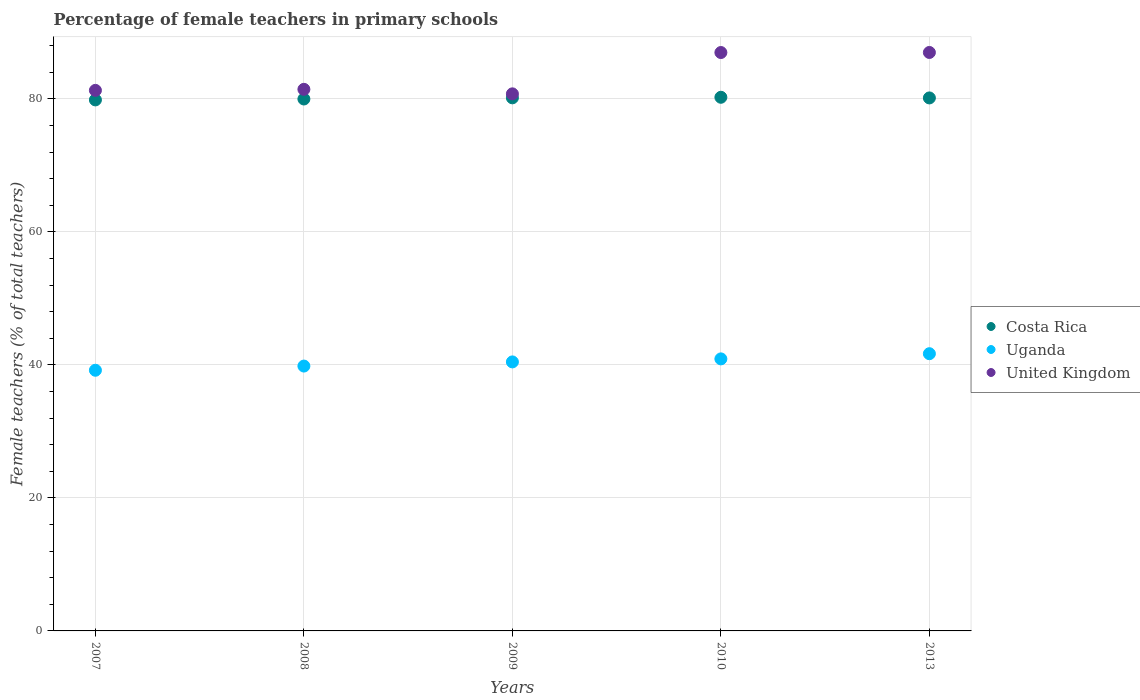How many different coloured dotlines are there?
Provide a succinct answer. 3. Is the number of dotlines equal to the number of legend labels?
Your answer should be very brief. Yes. What is the percentage of female teachers in Uganda in 2010?
Your answer should be very brief. 40.91. Across all years, what is the maximum percentage of female teachers in Costa Rica?
Your answer should be compact. 80.25. Across all years, what is the minimum percentage of female teachers in Uganda?
Offer a very short reply. 39.2. In which year was the percentage of female teachers in Costa Rica maximum?
Your answer should be compact. 2010. What is the total percentage of female teachers in Uganda in the graph?
Make the answer very short. 202.07. What is the difference between the percentage of female teachers in United Kingdom in 2010 and that in 2013?
Provide a succinct answer. -0.01. What is the difference between the percentage of female teachers in Uganda in 2009 and the percentage of female teachers in United Kingdom in 2008?
Ensure brevity in your answer.  -40.99. What is the average percentage of female teachers in Costa Rica per year?
Give a very brief answer. 80.08. In the year 2007, what is the difference between the percentage of female teachers in Costa Rica and percentage of female teachers in United Kingdom?
Keep it short and to the point. -1.43. In how many years, is the percentage of female teachers in Uganda greater than 24 %?
Offer a very short reply. 5. What is the ratio of the percentage of female teachers in Uganda in 2007 to that in 2008?
Your answer should be compact. 0.98. Is the percentage of female teachers in Uganda in 2007 less than that in 2009?
Your answer should be compact. Yes. What is the difference between the highest and the second highest percentage of female teachers in Uganda?
Your response must be concise. 0.78. What is the difference between the highest and the lowest percentage of female teachers in United Kingdom?
Offer a very short reply. 6.22. Is it the case that in every year, the sum of the percentage of female teachers in Uganda and percentage of female teachers in Costa Rica  is greater than the percentage of female teachers in United Kingdom?
Provide a short and direct response. Yes. Does the percentage of female teachers in Costa Rica monotonically increase over the years?
Your response must be concise. No. Is the percentage of female teachers in United Kingdom strictly greater than the percentage of female teachers in Uganda over the years?
Offer a very short reply. Yes. How many dotlines are there?
Provide a succinct answer. 3. Does the graph contain grids?
Your response must be concise. Yes. What is the title of the graph?
Provide a short and direct response. Percentage of female teachers in primary schools. What is the label or title of the X-axis?
Offer a terse response. Years. What is the label or title of the Y-axis?
Ensure brevity in your answer.  Female teachers (% of total teachers). What is the Female teachers (% of total teachers) of Costa Rica in 2007?
Provide a succinct answer. 79.85. What is the Female teachers (% of total teachers) of Uganda in 2007?
Provide a short and direct response. 39.2. What is the Female teachers (% of total teachers) of United Kingdom in 2007?
Your response must be concise. 81.28. What is the Female teachers (% of total teachers) in Costa Rica in 2008?
Ensure brevity in your answer.  79.99. What is the Female teachers (% of total teachers) of Uganda in 2008?
Provide a succinct answer. 39.83. What is the Female teachers (% of total teachers) of United Kingdom in 2008?
Provide a short and direct response. 81.44. What is the Female teachers (% of total teachers) in Costa Rica in 2009?
Provide a short and direct response. 80.16. What is the Female teachers (% of total teachers) of Uganda in 2009?
Your response must be concise. 40.45. What is the Female teachers (% of total teachers) of United Kingdom in 2009?
Offer a very short reply. 80.76. What is the Female teachers (% of total teachers) of Costa Rica in 2010?
Your answer should be compact. 80.25. What is the Female teachers (% of total teachers) of Uganda in 2010?
Your response must be concise. 40.91. What is the Female teachers (% of total teachers) of United Kingdom in 2010?
Make the answer very short. 86.98. What is the Female teachers (% of total teachers) of Costa Rica in 2013?
Your answer should be very brief. 80.15. What is the Female teachers (% of total teachers) in Uganda in 2013?
Ensure brevity in your answer.  41.69. What is the Female teachers (% of total teachers) of United Kingdom in 2013?
Provide a short and direct response. 86.98. Across all years, what is the maximum Female teachers (% of total teachers) in Costa Rica?
Give a very brief answer. 80.25. Across all years, what is the maximum Female teachers (% of total teachers) of Uganda?
Give a very brief answer. 41.69. Across all years, what is the maximum Female teachers (% of total teachers) in United Kingdom?
Your answer should be very brief. 86.98. Across all years, what is the minimum Female teachers (% of total teachers) of Costa Rica?
Your response must be concise. 79.85. Across all years, what is the minimum Female teachers (% of total teachers) of Uganda?
Provide a short and direct response. 39.2. Across all years, what is the minimum Female teachers (% of total teachers) of United Kingdom?
Your response must be concise. 80.76. What is the total Female teachers (% of total teachers) of Costa Rica in the graph?
Your answer should be very brief. 400.39. What is the total Female teachers (% of total teachers) in Uganda in the graph?
Give a very brief answer. 202.07. What is the total Female teachers (% of total teachers) in United Kingdom in the graph?
Provide a short and direct response. 417.45. What is the difference between the Female teachers (% of total teachers) of Costa Rica in 2007 and that in 2008?
Offer a very short reply. -0.14. What is the difference between the Female teachers (% of total teachers) of Uganda in 2007 and that in 2008?
Make the answer very short. -0.63. What is the difference between the Female teachers (% of total teachers) in United Kingdom in 2007 and that in 2008?
Give a very brief answer. -0.16. What is the difference between the Female teachers (% of total teachers) of Costa Rica in 2007 and that in 2009?
Provide a succinct answer. -0.31. What is the difference between the Female teachers (% of total teachers) in Uganda in 2007 and that in 2009?
Your answer should be compact. -1.25. What is the difference between the Female teachers (% of total teachers) in United Kingdom in 2007 and that in 2009?
Ensure brevity in your answer.  0.52. What is the difference between the Female teachers (% of total teachers) in Costa Rica in 2007 and that in 2010?
Provide a short and direct response. -0.4. What is the difference between the Female teachers (% of total teachers) in Uganda in 2007 and that in 2010?
Your response must be concise. -1.71. What is the difference between the Female teachers (% of total teachers) in United Kingdom in 2007 and that in 2010?
Provide a succinct answer. -5.69. What is the difference between the Female teachers (% of total teachers) of Costa Rica in 2007 and that in 2013?
Offer a terse response. -0.3. What is the difference between the Female teachers (% of total teachers) of Uganda in 2007 and that in 2013?
Provide a succinct answer. -2.49. What is the difference between the Female teachers (% of total teachers) of United Kingdom in 2007 and that in 2013?
Keep it short and to the point. -5.7. What is the difference between the Female teachers (% of total teachers) of Costa Rica in 2008 and that in 2009?
Offer a very short reply. -0.17. What is the difference between the Female teachers (% of total teachers) of Uganda in 2008 and that in 2009?
Your answer should be very brief. -0.62. What is the difference between the Female teachers (% of total teachers) in United Kingdom in 2008 and that in 2009?
Offer a terse response. 0.68. What is the difference between the Female teachers (% of total teachers) of Costa Rica in 2008 and that in 2010?
Your answer should be compact. -0.26. What is the difference between the Female teachers (% of total teachers) of Uganda in 2008 and that in 2010?
Your response must be concise. -1.08. What is the difference between the Female teachers (% of total teachers) of United Kingdom in 2008 and that in 2010?
Offer a very short reply. -5.53. What is the difference between the Female teachers (% of total teachers) of Costa Rica in 2008 and that in 2013?
Your response must be concise. -0.16. What is the difference between the Female teachers (% of total teachers) in Uganda in 2008 and that in 2013?
Provide a succinct answer. -1.86. What is the difference between the Female teachers (% of total teachers) in United Kingdom in 2008 and that in 2013?
Offer a very short reply. -5.54. What is the difference between the Female teachers (% of total teachers) in Costa Rica in 2009 and that in 2010?
Provide a short and direct response. -0.08. What is the difference between the Female teachers (% of total teachers) of Uganda in 2009 and that in 2010?
Make the answer very short. -0.45. What is the difference between the Female teachers (% of total teachers) in United Kingdom in 2009 and that in 2010?
Give a very brief answer. -6.21. What is the difference between the Female teachers (% of total teachers) of Costa Rica in 2009 and that in 2013?
Provide a short and direct response. 0.01. What is the difference between the Female teachers (% of total teachers) of Uganda in 2009 and that in 2013?
Offer a terse response. -1.23. What is the difference between the Female teachers (% of total teachers) in United Kingdom in 2009 and that in 2013?
Provide a short and direct response. -6.22. What is the difference between the Female teachers (% of total teachers) of Costa Rica in 2010 and that in 2013?
Your response must be concise. 0.1. What is the difference between the Female teachers (% of total teachers) in Uganda in 2010 and that in 2013?
Your response must be concise. -0.78. What is the difference between the Female teachers (% of total teachers) of United Kingdom in 2010 and that in 2013?
Your answer should be very brief. -0.01. What is the difference between the Female teachers (% of total teachers) of Costa Rica in 2007 and the Female teachers (% of total teachers) of Uganda in 2008?
Ensure brevity in your answer.  40.02. What is the difference between the Female teachers (% of total teachers) of Costa Rica in 2007 and the Female teachers (% of total teachers) of United Kingdom in 2008?
Your response must be concise. -1.59. What is the difference between the Female teachers (% of total teachers) of Uganda in 2007 and the Female teachers (% of total teachers) of United Kingdom in 2008?
Your answer should be very brief. -42.24. What is the difference between the Female teachers (% of total teachers) of Costa Rica in 2007 and the Female teachers (% of total teachers) of Uganda in 2009?
Make the answer very short. 39.4. What is the difference between the Female teachers (% of total teachers) in Costa Rica in 2007 and the Female teachers (% of total teachers) in United Kingdom in 2009?
Give a very brief answer. -0.91. What is the difference between the Female teachers (% of total teachers) in Uganda in 2007 and the Female teachers (% of total teachers) in United Kingdom in 2009?
Provide a succinct answer. -41.56. What is the difference between the Female teachers (% of total teachers) of Costa Rica in 2007 and the Female teachers (% of total teachers) of Uganda in 2010?
Your response must be concise. 38.94. What is the difference between the Female teachers (% of total teachers) of Costa Rica in 2007 and the Female teachers (% of total teachers) of United Kingdom in 2010?
Make the answer very short. -7.13. What is the difference between the Female teachers (% of total teachers) in Uganda in 2007 and the Female teachers (% of total teachers) in United Kingdom in 2010?
Keep it short and to the point. -47.78. What is the difference between the Female teachers (% of total teachers) of Costa Rica in 2007 and the Female teachers (% of total teachers) of Uganda in 2013?
Ensure brevity in your answer.  38.16. What is the difference between the Female teachers (% of total teachers) of Costa Rica in 2007 and the Female teachers (% of total teachers) of United Kingdom in 2013?
Your answer should be very brief. -7.13. What is the difference between the Female teachers (% of total teachers) of Uganda in 2007 and the Female teachers (% of total teachers) of United Kingdom in 2013?
Give a very brief answer. -47.79. What is the difference between the Female teachers (% of total teachers) in Costa Rica in 2008 and the Female teachers (% of total teachers) in Uganda in 2009?
Provide a succinct answer. 39.53. What is the difference between the Female teachers (% of total teachers) in Costa Rica in 2008 and the Female teachers (% of total teachers) in United Kingdom in 2009?
Provide a short and direct response. -0.77. What is the difference between the Female teachers (% of total teachers) in Uganda in 2008 and the Female teachers (% of total teachers) in United Kingdom in 2009?
Provide a succinct answer. -40.93. What is the difference between the Female teachers (% of total teachers) in Costa Rica in 2008 and the Female teachers (% of total teachers) in Uganda in 2010?
Keep it short and to the point. 39.08. What is the difference between the Female teachers (% of total teachers) in Costa Rica in 2008 and the Female teachers (% of total teachers) in United Kingdom in 2010?
Offer a very short reply. -6.99. What is the difference between the Female teachers (% of total teachers) of Uganda in 2008 and the Female teachers (% of total teachers) of United Kingdom in 2010?
Ensure brevity in your answer.  -47.15. What is the difference between the Female teachers (% of total teachers) of Costa Rica in 2008 and the Female teachers (% of total teachers) of Uganda in 2013?
Make the answer very short. 38.3. What is the difference between the Female teachers (% of total teachers) in Costa Rica in 2008 and the Female teachers (% of total teachers) in United Kingdom in 2013?
Give a very brief answer. -7. What is the difference between the Female teachers (% of total teachers) in Uganda in 2008 and the Female teachers (% of total teachers) in United Kingdom in 2013?
Your response must be concise. -47.16. What is the difference between the Female teachers (% of total teachers) in Costa Rica in 2009 and the Female teachers (% of total teachers) in Uganda in 2010?
Your answer should be compact. 39.25. What is the difference between the Female teachers (% of total teachers) of Costa Rica in 2009 and the Female teachers (% of total teachers) of United Kingdom in 2010?
Give a very brief answer. -6.81. What is the difference between the Female teachers (% of total teachers) of Uganda in 2009 and the Female teachers (% of total teachers) of United Kingdom in 2010?
Provide a short and direct response. -46.52. What is the difference between the Female teachers (% of total teachers) in Costa Rica in 2009 and the Female teachers (% of total teachers) in Uganda in 2013?
Provide a short and direct response. 38.48. What is the difference between the Female teachers (% of total teachers) in Costa Rica in 2009 and the Female teachers (% of total teachers) in United Kingdom in 2013?
Keep it short and to the point. -6.82. What is the difference between the Female teachers (% of total teachers) in Uganda in 2009 and the Female teachers (% of total teachers) in United Kingdom in 2013?
Provide a succinct answer. -46.53. What is the difference between the Female teachers (% of total teachers) of Costa Rica in 2010 and the Female teachers (% of total teachers) of Uganda in 2013?
Ensure brevity in your answer.  38.56. What is the difference between the Female teachers (% of total teachers) in Costa Rica in 2010 and the Female teachers (% of total teachers) in United Kingdom in 2013?
Ensure brevity in your answer.  -6.74. What is the difference between the Female teachers (% of total teachers) in Uganda in 2010 and the Female teachers (% of total teachers) in United Kingdom in 2013?
Offer a very short reply. -46.08. What is the average Female teachers (% of total teachers) in Costa Rica per year?
Ensure brevity in your answer.  80.08. What is the average Female teachers (% of total teachers) in Uganda per year?
Make the answer very short. 40.41. What is the average Female teachers (% of total teachers) of United Kingdom per year?
Offer a terse response. 83.49. In the year 2007, what is the difference between the Female teachers (% of total teachers) of Costa Rica and Female teachers (% of total teachers) of Uganda?
Make the answer very short. 40.65. In the year 2007, what is the difference between the Female teachers (% of total teachers) of Costa Rica and Female teachers (% of total teachers) of United Kingdom?
Your response must be concise. -1.43. In the year 2007, what is the difference between the Female teachers (% of total teachers) of Uganda and Female teachers (% of total teachers) of United Kingdom?
Your answer should be compact. -42.09. In the year 2008, what is the difference between the Female teachers (% of total teachers) of Costa Rica and Female teachers (% of total teachers) of Uganda?
Offer a terse response. 40.16. In the year 2008, what is the difference between the Female teachers (% of total teachers) of Costa Rica and Female teachers (% of total teachers) of United Kingdom?
Keep it short and to the point. -1.45. In the year 2008, what is the difference between the Female teachers (% of total teachers) of Uganda and Female teachers (% of total teachers) of United Kingdom?
Your answer should be compact. -41.61. In the year 2009, what is the difference between the Female teachers (% of total teachers) of Costa Rica and Female teachers (% of total teachers) of Uganda?
Offer a very short reply. 39.71. In the year 2009, what is the difference between the Female teachers (% of total teachers) in Costa Rica and Female teachers (% of total teachers) in United Kingdom?
Give a very brief answer. -0.6. In the year 2009, what is the difference between the Female teachers (% of total teachers) of Uganda and Female teachers (% of total teachers) of United Kingdom?
Offer a terse response. -40.31. In the year 2010, what is the difference between the Female teachers (% of total teachers) in Costa Rica and Female teachers (% of total teachers) in Uganda?
Provide a succinct answer. 39.34. In the year 2010, what is the difference between the Female teachers (% of total teachers) of Costa Rica and Female teachers (% of total teachers) of United Kingdom?
Make the answer very short. -6.73. In the year 2010, what is the difference between the Female teachers (% of total teachers) of Uganda and Female teachers (% of total teachers) of United Kingdom?
Provide a short and direct response. -46.07. In the year 2013, what is the difference between the Female teachers (% of total teachers) of Costa Rica and Female teachers (% of total teachers) of Uganda?
Provide a succinct answer. 38.46. In the year 2013, what is the difference between the Female teachers (% of total teachers) in Costa Rica and Female teachers (% of total teachers) in United Kingdom?
Provide a short and direct response. -6.84. In the year 2013, what is the difference between the Female teachers (% of total teachers) in Uganda and Female teachers (% of total teachers) in United Kingdom?
Give a very brief answer. -45.3. What is the ratio of the Female teachers (% of total teachers) in Uganda in 2007 to that in 2008?
Your answer should be very brief. 0.98. What is the ratio of the Female teachers (% of total teachers) of United Kingdom in 2007 to that in 2009?
Ensure brevity in your answer.  1.01. What is the ratio of the Female teachers (% of total teachers) in Uganda in 2007 to that in 2010?
Make the answer very short. 0.96. What is the ratio of the Female teachers (% of total teachers) in United Kingdom in 2007 to that in 2010?
Ensure brevity in your answer.  0.93. What is the ratio of the Female teachers (% of total teachers) of Uganda in 2007 to that in 2013?
Offer a very short reply. 0.94. What is the ratio of the Female teachers (% of total teachers) of United Kingdom in 2007 to that in 2013?
Offer a very short reply. 0.93. What is the ratio of the Female teachers (% of total teachers) in Uganda in 2008 to that in 2009?
Make the answer very short. 0.98. What is the ratio of the Female teachers (% of total teachers) in United Kingdom in 2008 to that in 2009?
Your answer should be compact. 1.01. What is the ratio of the Female teachers (% of total teachers) in Costa Rica in 2008 to that in 2010?
Offer a terse response. 1. What is the ratio of the Female teachers (% of total teachers) in Uganda in 2008 to that in 2010?
Your response must be concise. 0.97. What is the ratio of the Female teachers (% of total teachers) in United Kingdom in 2008 to that in 2010?
Offer a terse response. 0.94. What is the ratio of the Female teachers (% of total teachers) in Uganda in 2008 to that in 2013?
Ensure brevity in your answer.  0.96. What is the ratio of the Female teachers (% of total teachers) of United Kingdom in 2008 to that in 2013?
Make the answer very short. 0.94. What is the ratio of the Female teachers (% of total teachers) of Costa Rica in 2009 to that in 2010?
Your answer should be very brief. 1. What is the ratio of the Female teachers (% of total teachers) in Uganda in 2009 to that in 2010?
Ensure brevity in your answer.  0.99. What is the ratio of the Female teachers (% of total teachers) in United Kingdom in 2009 to that in 2010?
Ensure brevity in your answer.  0.93. What is the ratio of the Female teachers (% of total teachers) in Uganda in 2009 to that in 2013?
Offer a terse response. 0.97. What is the ratio of the Female teachers (% of total teachers) in United Kingdom in 2009 to that in 2013?
Offer a very short reply. 0.93. What is the ratio of the Female teachers (% of total teachers) in Costa Rica in 2010 to that in 2013?
Your answer should be very brief. 1. What is the ratio of the Female teachers (% of total teachers) of Uganda in 2010 to that in 2013?
Offer a terse response. 0.98. What is the ratio of the Female teachers (% of total teachers) in United Kingdom in 2010 to that in 2013?
Keep it short and to the point. 1. What is the difference between the highest and the second highest Female teachers (% of total teachers) of Costa Rica?
Provide a succinct answer. 0.08. What is the difference between the highest and the second highest Female teachers (% of total teachers) in Uganda?
Your answer should be compact. 0.78. What is the difference between the highest and the second highest Female teachers (% of total teachers) in United Kingdom?
Your answer should be compact. 0.01. What is the difference between the highest and the lowest Female teachers (% of total teachers) of Costa Rica?
Give a very brief answer. 0.4. What is the difference between the highest and the lowest Female teachers (% of total teachers) of Uganda?
Provide a short and direct response. 2.49. What is the difference between the highest and the lowest Female teachers (% of total teachers) in United Kingdom?
Make the answer very short. 6.22. 